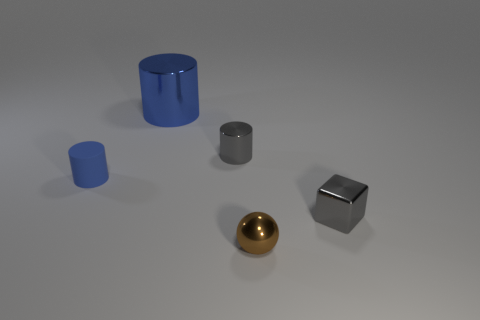Subtract all brown balls. How many blue cylinders are left? 2 Add 4 blue metal cylinders. How many objects exist? 9 Subtract all cubes. How many objects are left? 4 Subtract 0 brown blocks. How many objects are left? 5 Subtract all metal cylinders. Subtract all gray shiny things. How many objects are left? 1 Add 4 brown shiny balls. How many brown shiny balls are left? 5 Add 4 large blue metal things. How many large blue metal things exist? 5 